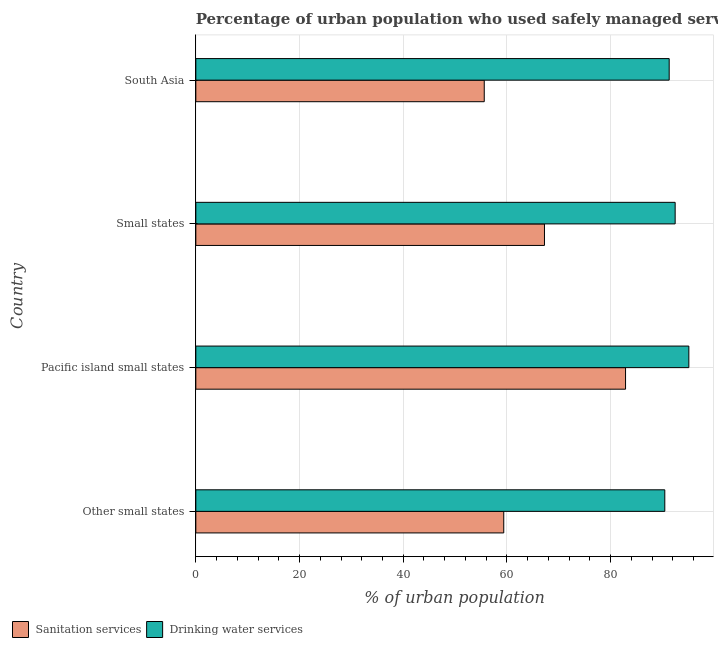How many groups of bars are there?
Offer a terse response. 4. Are the number of bars per tick equal to the number of legend labels?
Provide a succinct answer. Yes. How many bars are there on the 4th tick from the top?
Provide a succinct answer. 2. What is the label of the 2nd group of bars from the top?
Offer a terse response. Small states. In how many cases, is the number of bars for a given country not equal to the number of legend labels?
Your response must be concise. 0. What is the percentage of urban population who used sanitation services in Small states?
Keep it short and to the point. 67.24. Across all countries, what is the maximum percentage of urban population who used drinking water services?
Provide a short and direct response. 95.08. Across all countries, what is the minimum percentage of urban population who used drinking water services?
Ensure brevity in your answer.  90.45. In which country was the percentage of urban population who used sanitation services maximum?
Provide a succinct answer. Pacific island small states. In which country was the percentage of urban population who used drinking water services minimum?
Provide a succinct answer. Other small states. What is the total percentage of urban population who used sanitation services in the graph?
Provide a short and direct response. 265.13. What is the difference between the percentage of urban population who used sanitation services in Small states and that in South Asia?
Your answer should be compact. 11.61. What is the difference between the percentage of urban population who used sanitation services in South Asia and the percentage of urban population who used drinking water services in Pacific island small states?
Provide a short and direct response. -39.46. What is the average percentage of urban population who used sanitation services per country?
Keep it short and to the point. 66.28. What is the difference between the percentage of urban population who used drinking water services and percentage of urban population who used sanitation services in Other small states?
Ensure brevity in your answer.  31.06. What is the ratio of the percentage of urban population who used sanitation services in Other small states to that in South Asia?
Ensure brevity in your answer.  1.07. What is the difference between the highest and the second highest percentage of urban population who used drinking water services?
Your response must be concise. 2.64. What is the difference between the highest and the lowest percentage of urban population who used sanitation services?
Provide a short and direct response. 27.25. In how many countries, is the percentage of urban population who used sanitation services greater than the average percentage of urban population who used sanitation services taken over all countries?
Your answer should be compact. 2. What does the 1st bar from the top in South Asia represents?
Your response must be concise. Drinking water services. What does the 2nd bar from the bottom in South Asia represents?
Offer a terse response. Drinking water services. How many countries are there in the graph?
Your answer should be very brief. 4. What is the title of the graph?
Provide a short and direct response. Percentage of urban population who used safely managed services in 1999. Does "Male entrants" appear as one of the legend labels in the graph?
Give a very brief answer. No. What is the label or title of the X-axis?
Your answer should be very brief. % of urban population. What is the label or title of the Y-axis?
Make the answer very short. Country. What is the % of urban population in Sanitation services in Other small states?
Ensure brevity in your answer.  59.39. What is the % of urban population of Drinking water services in Other small states?
Provide a short and direct response. 90.45. What is the % of urban population in Sanitation services in Pacific island small states?
Ensure brevity in your answer.  82.88. What is the % of urban population of Drinking water services in Pacific island small states?
Your answer should be very brief. 95.08. What is the % of urban population in Sanitation services in Small states?
Your answer should be compact. 67.24. What is the % of urban population in Drinking water services in Small states?
Offer a terse response. 92.44. What is the % of urban population in Sanitation services in South Asia?
Your response must be concise. 55.63. What is the % of urban population of Drinking water services in South Asia?
Give a very brief answer. 91.29. Across all countries, what is the maximum % of urban population in Sanitation services?
Ensure brevity in your answer.  82.88. Across all countries, what is the maximum % of urban population in Drinking water services?
Keep it short and to the point. 95.08. Across all countries, what is the minimum % of urban population of Sanitation services?
Keep it short and to the point. 55.63. Across all countries, what is the minimum % of urban population of Drinking water services?
Provide a succinct answer. 90.45. What is the total % of urban population of Sanitation services in the graph?
Ensure brevity in your answer.  265.13. What is the total % of urban population in Drinking water services in the graph?
Provide a short and direct response. 369.26. What is the difference between the % of urban population in Sanitation services in Other small states and that in Pacific island small states?
Make the answer very short. -23.49. What is the difference between the % of urban population in Drinking water services in Other small states and that in Pacific island small states?
Keep it short and to the point. -4.64. What is the difference between the % of urban population of Sanitation services in Other small states and that in Small states?
Your response must be concise. -7.85. What is the difference between the % of urban population in Drinking water services in Other small states and that in Small states?
Offer a very short reply. -2. What is the difference between the % of urban population of Sanitation services in Other small states and that in South Asia?
Your answer should be compact. 3.76. What is the difference between the % of urban population of Drinking water services in Other small states and that in South Asia?
Your answer should be very brief. -0.85. What is the difference between the % of urban population in Sanitation services in Pacific island small states and that in Small states?
Your answer should be compact. 15.64. What is the difference between the % of urban population in Drinking water services in Pacific island small states and that in Small states?
Your response must be concise. 2.64. What is the difference between the % of urban population of Sanitation services in Pacific island small states and that in South Asia?
Give a very brief answer. 27.25. What is the difference between the % of urban population of Drinking water services in Pacific island small states and that in South Asia?
Your response must be concise. 3.79. What is the difference between the % of urban population in Sanitation services in Small states and that in South Asia?
Provide a short and direct response. 11.61. What is the difference between the % of urban population of Drinking water services in Small states and that in South Asia?
Ensure brevity in your answer.  1.15. What is the difference between the % of urban population of Sanitation services in Other small states and the % of urban population of Drinking water services in Pacific island small states?
Offer a terse response. -35.7. What is the difference between the % of urban population of Sanitation services in Other small states and the % of urban population of Drinking water services in Small states?
Provide a short and direct response. -33.06. What is the difference between the % of urban population of Sanitation services in Other small states and the % of urban population of Drinking water services in South Asia?
Your answer should be compact. -31.9. What is the difference between the % of urban population in Sanitation services in Pacific island small states and the % of urban population in Drinking water services in Small states?
Offer a terse response. -9.57. What is the difference between the % of urban population in Sanitation services in Pacific island small states and the % of urban population in Drinking water services in South Asia?
Offer a terse response. -8.41. What is the difference between the % of urban population in Sanitation services in Small states and the % of urban population in Drinking water services in South Asia?
Your response must be concise. -24.05. What is the average % of urban population of Sanitation services per country?
Ensure brevity in your answer.  66.28. What is the average % of urban population in Drinking water services per country?
Your answer should be compact. 92.32. What is the difference between the % of urban population in Sanitation services and % of urban population in Drinking water services in Other small states?
Your answer should be compact. -31.06. What is the difference between the % of urban population of Sanitation services and % of urban population of Drinking water services in Pacific island small states?
Offer a very short reply. -12.21. What is the difference between the % of urban population in Sanitation services and % of urban population in Drinking water services in Small states?
Provide a short and direct response. -25.2. What is the difference between the % of urban population of Sanitation services and % of urban population of Drinking water services in South Asia?
Provide a succinct answer. -35.67. What is the ratio of the % of urban population of Sanitation services in Other small states to that in Pacific island small states?
Offer a very short reply. 0.72. What is the ratio of the % of urban population in Drinking water services in Other small states to that in Pacific island small states?
Provide a short and direct response. 0.95. What is the ratio of the % of urban population of Sanitation services in Other small states to that in Small states?
Your answer should be compact. 0.88. What is the ratio of the % of urban population of Drinking water services in Other small states to that in Small states?
Your answer should be very brief. 0.98. What is the ratio of the % of urban population of Sanitation services in Other small states to that in South Asia?
Keep it short and to the point. 1.07. What is the ratio of the % of urban population in Drinking water services in Other small states to that in South Asia?
Offer a terse response. 0.99. What is the ratio of the % of urban population of Sanitation services in Pacific island small states to that in Small states?
Your answer should be compact. 1.23. What is the ratio of the % of urban population of Drinking water services in Pacific island small states to that in Small states?
Offer a terse response. 1.03. What is the ratio of the % of urban population of Sanitation services in Pacific island small states to that in South Asia?
Your answer should be very brief. 1.49. What is the ratio of the % of urban population in Drinking water services in Pacific island small states to that in South Asia?
Provide a succinct answer. 1.04. What is the ratio of the % of urban population in Sanitation services in Small states to that in South Asia?
Your answer should be compact. 1.21. What is the ratio of the % of urban population in Drinking water services in Small states to that in South Asia?
Give a very brief answer. 1.01. What is the difference between the highest and the second highest % of urban population of Sanitation services?
Keep it short and to the point. 15.64. What is the difference between the highest and the second highest % of urban population in Drinking water services?
Offer a terse response. 2.64. What is the difference between the highest and the lowest % of urban population of Sanitation services?
Provide a succinct answer. 27.25. What is the difference between the highest and the lowest % of urban population of Drinking water services?
Your answer should be compact. 4.64. 